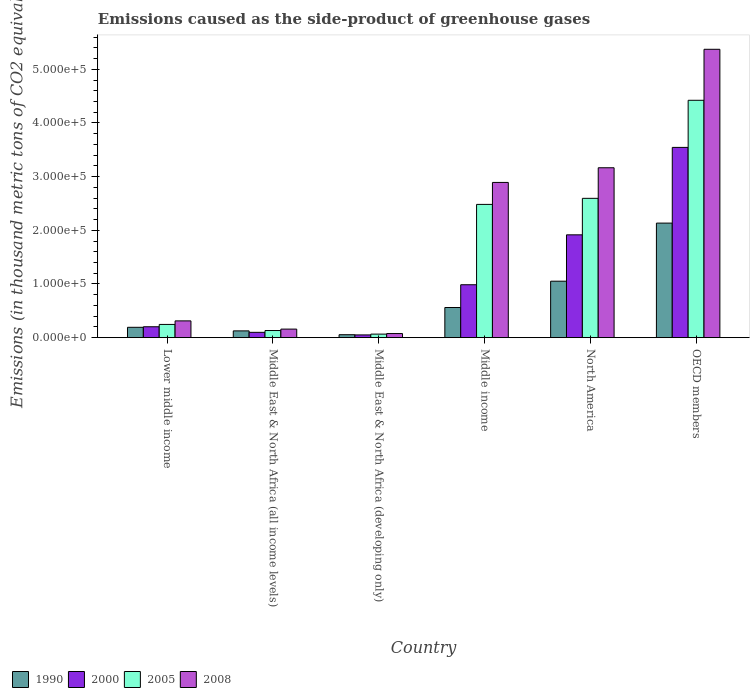How many groups of bars are there?
Your answer should be very brief. 6. Are the number of bars per tick equal to the number of legend labels?
Your answer should be compact. Yes. How many bars are there on the 6th tick from the left?
Keep it short and to the point. 4. What is the label of the 6th group of bars from the left?
Provide a succinct answer. OECD members. In how many cases, is the number of bars for a given country not equal to the number of legend labels?
Make the answer very short. 0. What is the emissions caused as the side-product of greenhouse gases in 1990 in Middle East & North Africa (all income levels)?
Give a very brief answer. 1.26e+04. Across all countries, what is the maximum emissions caused as the side-product of greenhouse gases in 2005?
Provide a succinct answer. 4.42e+05. Across all countries, what is the minimum emissions caused as the side-product of greenhouse gases in 1990?
Provide a succinct answer. 5502.6. In which country was the emissions caused as the side-product of greenhouse gases in 2005 minimum?
Provide a short and direct response. Middle East & North Africa (developing only). What is the total emissions caused as the side-product of greenhouse gases in 1990 in the graph?
Offer a terse response. 4.12e+05. What is the difference between the emissions caused as the side-product of greenhouse gases in 2008 in Middle East & North Africa (all income levels) and that in OECD members?
Make the answer very short. -5.21e+05. What is the difference between the emissions caused as the side-product of greenhouse gases in 2005 in Middle East & North Africa (all income levels) and the emissions caused as the side-product of greenhouse gases in 2000 in Middle income?
Your answer should be very brief. -8.53e+04. What is the average emissions caused as the side-product of greenhouse gases in 2008 per country?
Your response must be concise. 2.00e+05. What is the difference between the emissions caused as the side-product of greenhouse gases of/in 2005 and emissions caused as the side-product of greenhouse gases of/in 2008 in OECD members?
Keep it short and to the point. -9.50e+04. What is the ratio of the emissions caused as the side-product of greenhouse gases in 2000 in Middle East & North Africa (all income levels) to that in North America?
Ensure brevity in your answer.  0.05. Is the emissions caused as the side-product of greenhouse gases in 1990 in Middle income less than that in North America?
Ensure brevity in your answer.  Yes. What is the difference between the highest and the second highest emissions caused as the side-product of greenhouse gases in 2000?
Your response must be concise. -9.30e+04. What is the difference between the highest and the lowest emissions caused as the side-product of greenhouse gases in 2008?
Offer a terse response. 5.30e+05. In how many countries, is the emissions caused as the side-product of greenhouse gases in 2000 greater than the average emissions caused as the side-product of greenhouse gases in 2000 taken over all countries?
Keep it short and to the point. 2. Is the sum of the emissions caused as the side-product of greenhouse gases in 2005 in Middle East & North Africa (developing only) and OECD members greater than the maximum emissions caused as the side-product of greenhouse gases in 1990 across all countries?
Your response must be concise. Yes. Is it the case that in every country, the sum of the emissions caused as the side-product of greenhouse gases in 2008 and emissions caused as the side-product of greenhouse gases in 2005 is greater than the sum of emissions caused as the side-product of greenhouse gases in 1990 and emissions caused as the side-product of greenhouse gases in 2000?
Offer a terse response. No. What does the 3rd bar from the left in North America represents?
Your answer should be very brief. 2005. How many bars are there?
Ensure brevity in your answer.  24. What is the difference between two consecutive major ticks on the Y-axis?
Provide a short and direct response. 1.00e+05. Does the graph contain any zero values?
Your answer should be very brief. No. Where does the legend appear in the graph?
Your answer should be very brief. Bottom left. How many legend labels are there?
Make the answer very short. 4. What is the title of the graph?
Your response must be concise. Emissions caused as the side-product of greenhouse gases. Does "1971" appear as one of the legend labels in the graph?
Offer a terse response. No. What is the label or title of the X-axis?
Your response must be concise. Country. What is the label or title of the Y-axis?
Offer a very short reply. Emissions (in thousand metric tons of CO2 equivalent). What is the Emissions (in thousand metric tons of CO2 equivalent) of 1990 in Lower middle income?
Keep it short and to the point. 1.93e+04. What is the Emissions (in thousand metric tons of CO2 equivalent) in 2000 in Lower middle income?
Ensure brevity in your answer.  2.03e+04. What is the Emissions (in thousand metric tons of CO2 equivalent) in 2005 in Lower middle income?
Ensure brevity in your answer.  2.47e+04. What is the Emissions (in thousand metric tons of CO2 equivalent) in 2008 in Lower middle income?
Your response must be concise. 3.13e+04. What is the Emissions (in thousand metric tons of CO2 equivalent) in 1990 in Middle East & North Africa (all income levels)?
Your answer should be very brief. 1.26e+04. What is the Emissions (in thousand metric tons of CO2 equivalent) of 2000 in Middle East & North Africa (all income levels)?
Offer a very short reply. 9923.6. What is the Emissions (in thousand metric tons of CO2 equivalent) in 2005 in Middle East & North Africa (all income levels)?
Provide a short and direct response. 1.33e+04. What is the Emissions (in thousand metric tons of CO2 equivalent) in 2008 in Middle East & North Africa (all income levels)?
Make the answer very short. 1.60e+04. What is the Emissions (in thousand metric tons of CO2 equivalent) in 1990 in Middle East & North Africa (developing only)?
Provide a short and direct response. 5502.6. What is the Emissions (in thousand metric tons of CO2 equivalent) of 2000 in Middle East & North Africa (developing only)?
Give a very brief answer. 5124.9. What is the Emissions (in thousand metric tons of CO2 equivalent) in 2005 in Middle East & North Africa (developing only)?
Your response must be concise. 6617.8. What is the Emissions (in thousand metric tons of CO2 equivalent) in 2008 in Middle East & North Africa (developing only)?
Provide a short and direct response. 7657.2. What is the Emissions (in thousand metric tons of CO2 equivalent) of 1990 in Middle income?
Provide a succinct answer. 5.62e+04. What is the Emissions (in thousand metric tons of CO2 equivalent) of 2000 in Middle income?
Your answer should be compact. 9.86e+04. What is the Emissions (in thousand metric tons of CO2 equivalent) in 2005 in Middle income?
Offer a very short reply. 2.48e+05. What is the Emissions (in thousand metric tons of CO2 equivalent) in 2008 in Middle income?
Make the answer very short. 2.89e+05. What is the Emissions (in thousand metric tons of CO2 equivalent) of 1990 in North America?
Offer a very short reply. 1.05e+05. What is the Emissions (in thousand metric tons of CO2 equivalent) in 2000 in North America?
Provide a succinct answer. 1.92e+05. What is the Emissions (in thousand metric tons of CO2 equivalent) of 2005 in North America?
Keep it short and to the point. 2.60e+05. What is the Emissions (in thousand metric tons of CO2 equivalent) in 2008 in North America?
Your answer should be compact. 3.17e+05. What is the Emissions (in thousand metric tons of CO2 equivalent) of 1990 in OECD members?
Keep it short and to the point. 2.13e+05. What is the Emissions (in thousand metric tons of CO2 equivalent) of 2000 in OECD members?
Keep it short and to the point. 3.54e+05. What is the Emissions (in thousand metric tons of CO2 equivalent) of 2005 in OECD members?
Keep it short and to the point. 4.42e+05. What is the Emissions (in thousand metric tons of CO2 equivalent) of 2008 in OECD members?
Your answer should be compact. 5.37e+05. Across all countries, what is the maximum Emissions (in thousand metric tons of CO2 equivalent) of 1990?
Make the answer very short. 2.13e+05. Across all countries, what is the maximum Emissions (in thousand metric tons of CO2 equivalent) of 2000?
Provide a short and direct response. 3.54e+05. Across all countries, what is the maximum Emissions (in thousand metric tons of CO2 equivalent) in 2005?
Ensure brevity in your answer.  4.42e+05. Across all countries, what is the maximum Emissions (in thousand metric tons of CO2 equivalent) in 2008?
Give a very brief answer. 5.37e+05. Across all countries, what is the minimum Emissions (in thousand metric tons of CO2 equivalent) of 1990?
Offer a very short reply. 5502.6. Across all countries, what is the minimum Emissions (in thousand metric tons of CO2 equivalent) of 2000?
Provide a short and direct response. 5124.9. Across all countries, what is the minimum Emissions (in thousand metric tons of CO2 equivalent) of 2005?
Your answer should be very brief. 6617.8. Across all countries, what is the minimum Emissions (in thousand metric tons of CO2 equivalent) of 2008?
Offer a terse response. 7657.2. What is the total Emissions (in thousand metric tons of CO2 equivalent) of 1990 in the graph?
Your response must be concise. 4.12e+05. What is the total Emissions (in thousand metric tons of CO2 equivalent) in 2000 in the graph?
Ensure brevity in your answer.  6.80e+05. What is the total Emissions (in thousand metric tons of CO2 equivalent) in 2005 in the graph?
Provide a succinct answer. 9.95e+05. What is the total Emissions (in thousand metric tons of CO2 equivalent) of 2008 in the graph?
Offer a very short reply. 1.20e+06. What is the difference between the Emissions (in thousand metric tons of CO2 equivalent) in 1990 in Lower middle income and that in Middle East & North Africa (all income levels)?
Offer a terse response. 6670.8. What is the difference between the Emissions (in thousand metric tons of CO2 equivalent) of 2000 in Lower middle income and that in Middle East & North Africa (all income levels)?
Keep it short and to the point. 1.04e+04. What is the difference between the Emissions (in thousand metric tons of CO2 equivalent) in 2005 in Lower middle income and that in Middle East & North Africa (all income levels)?
Make the answer very short. 1.13e+04. What is the difference between the Emissions (in thousand metric tons of CO2 equivalent) in 2008 in Lower middle income and that in Middle East & North Africa (all income levels)?
Your answer should be very brief. 1.53e+04. What is the difference between the Emissions (in thousand metric tons of CO2 equivalent) of 1990 in Lower middle income and that in Middle East & North Africa (developing only)?
Your answer should be compact. 1.38e+04. What is the difference between the Emissions (in thousand metric tons of CO2 equivalent) in 2000 in Lower middle income and that in Middle East & North Africa (developing only)?
Make the answer very short. 1.52e+04. What is the difference between the Emissions (in thousand metric tons of CO2 equivalent) in 2005 in Lower middle income and that in Middle East & North Africa (developing only)?
Your answer should be compact. 1.80e+04. What is the difference between the Emissions (in thousand metric tons of CO2 equivalent) of 2008 in Lower middle income and that in Middle East & North Africa (developing only)?
Ensure brevity in your answer.  2.36e+04. What is the difference between the Emissions (in thousand metric tons of CO2 equivalent) of 1990 in Lower middle income and that in Middle income?
Provide a succinct answer. -3.69e+04. What is the difference between the Emissions (in thousand metric tons of CO2 equivalent) of 2000 in Lower middle income and that in Middle income?
Offer a very short reply. -7.83e+04. What is the difference between the Emissions (in thousand metric tons of CO2 equivalent) of 2005 in Lower middle income and that in Middle income?
Offer a terse response. -2.24e+05. What is the difference between the Emissions (in thousand metric tons of CO2 equivalent) in 2008 in Lower middle income and that in Middle income?
Your answer should be very brief. -2.58e+05. What is the difference between the Emissions (in thousand metric tons of CO2 equivalent) in 1990 in Lower middle income and that in North America?
Make the answer very short. -8.59e+04. What is the difference between the Emissions (in thousand metric tons of CO2 equivalent) of 2000 in Lower middle income and that in North America?
Provide a succinct answer. -1.71e+05. What is the difference between the Emissions (in thousand metric tons of CO2 equivalent) in 2005 in Lower middle income and that in North America?
Offer a terse response. -2.35e+05. What is the difference between the Emissions (in thousand metric tons of CO2 equivalent) in 2008 in Lower middle income and that in North America?
Provide a short and direct response. -2.85e+05. What is the difference between the Emissions (in thousand metric tons of CO2 equivalent) of 1990 in Lower middle income and that in OECD members?
Offer a terse response. -1.94e+05. What is the difference between the Emissions (in thousand metric tons of CO2 equivalent) in 2000 in Lower middle income and that in OECD members?
Provide a short and direct response. -3.34e+05. What is the difference between the Emissions (in thousand metric tons of CO2 equivalent) of 2005 in Lower middle income and that in OECD members?
Keep it short and to the point. -4.18e+05. What is the difference between the Emissions (in thousand metric tons of CO2 equivalent) in 2008 in Lower middle income and that in OECD members?
Offer a very short reply. -5.06e+05. What is the difference between the Emissions (in thousand metric tons of CO2 equivalent) in 1990 in Middle East & North Africa (all income levels) and that in Middle East & North Africa (developing only)?
Your answer should be very brief. 7133. What is the difference between the Emissions (in thousand metric tons of CO2 equivalent) of 2000 in Middle East & North Africa (all income levels) and that in Middle East & North Africa (developing only)?
Provide a succinct answer. 4798.7. What is the difference between the Emissions (in thousand metric tons of CO2 equivalent) of 2005 in Middle East & North Africa (all income levels) and that in Middle East & North Africa (developing only)?
Give a very brief answer. 6694.2. What is the difference between the Emissions (in thousand metric tons of CO2 equivalent) in 2008 in Middle East & North Africa (all income levels) and that in Middle East & North Africa (developing only)?
Your response must be concise. 8295.8. What is the difference between the Emissions (in thousand metric tons of CO2 equivalent) of 1990 in Middle East & North Africa (all income levels) and that in Middle income?
Offer a very short reply. -4.35e+04. What is the difference between the Emissions (in thousand metric tons of CO2 equivalent) of 2000 in Middle East & North Africa (all income levels) and that in Middle income?
Keep it short and to the point. -8.87e+04. What is the difference between the Emissions (in thousand metric tons of CO2 equivalent) in 2005 in Middle East & North Africa (all income levels) and that in Middle income?
Keep it short and to the point. -2.35e+05. What is the difference between the Emissions (in thousand metric tons of CO2 equivalent) of 2008 in Middle East & North Africa (all income levels) and that in Middle income?
Offer a terse response. -2.73e+05. What is the difference between the Emissions (in thousand metric tons of CO2 equivalent) in 1990 in Middle East & North Africa (all income levels) and that in North America?
Give a very brief answer. -9.26e+04. What is the difference between the Emissions (in thousand metric tons of CO2 equivalent) of 2000 in Middle East & North Africa (all income levels) and that in North America?
Make the answer very short. -1.82e+05. What is the difference between the Emissions (in thousand metric tons of CO2 equivalent) of 2005 in Middle East & North Africa (all income levels) and that in North America?
Keep it short and to the point. -2.46e+05. What is the difference between the Emissions (in thousand metric tons of CO2 equivalent) in 2008 in Middle East & North Africa (all income levels) and that in North America?
Provide a succinct answer. -3.01e+05. What is the difference between the Emissions (in thousand metric tons of CO2 equivalent) of 1990 in Middle East & North Africa (all income levels) and that in OECD members?
Provide a short and direct response. -2.01e+05. What is the difference between the Emissions (in thousand metric tons of CO2 equivalent) of 2000 in Middle East & North Africa (all income levels) and that in OECD members?
Make the answer very short. -3.45e+05. What is the difference between the Emissions (in thousand metric tons of CO2 equivalent) of 2005 in Middle East & North Africa (all income levels) and that in OECD members?
Keep it short and to the point. -4.29e+05. What is the difference between the Emissions (in thousand metric tons of CO2 equivalent) in 2008 in Middle East & North Africa (all income levels) and that in OECD members?
Ensure brevity in your answer.  -5.21e+05. What is the difference between the Emissions (in thousand metric tons of CO2 equivalent) in 1990 in Middle East & North Africa (developing only) and that in Middle income?
Make the answer very short. -5.07e+04. What is the difference between the Emissions (in thousand metric tons of CO2 equivalent) in 2000 in Middle East & North Africa (developing only) and that in Middle income?
Provide a succinct answer. -9.35e+04. What is the difference between the Emissions (in thousand metric tons of CO2 equivalent) of 2005 in Middle East & North Africa (developing only) and that in Middle income?
Keep it short and to the point. -2.42e+05. What is the difference between the Emissions (in thousand metric tons of CO2 equivalent) of 2008 in Middle East & North Africa (developing only) and that in Middle income?
Your answer should be compact. -2.82e+05. What is the difference between the Emissions (in thousand metric tons of CO2 equivalent) in 1990 in Middle East & North Africa (developing only) and that in North America?
Give a very brief answer. -9.97e+04. What is the difference between the Emissions (in thousand metric tons of CO2 equivalent) in 2000 in Middle East & North Africa (developing only) and that in North America?
Offer a terse response. -1.86e+05. What is the difference between the Emissions (in thousand metric tons of CO2 equivalent) of 2005 in Middle East & North Africa (developing only) and that in North America?
Keep it short and to the point. -2.53e+05. What is the difference between the Emissions (in thousand metric tons of CO2 equivalent) in 2008 in Middle East & North Africa (developing only) and that in North America?
Provide a succinct answer. -3.09e+05. What is the difference between the Emissions (in thousand metric tons of CO2 equivalent) in 1990 in Middle East & North Africa (developing only) and that in OECD members?
Ensure brevity in your answer.  -2.08e+05. What is the difference between the Emissions (in thousand metric tons of CO2 equivalent) of 2000 in Middle East & North Africa (developing only) and that in OECD members?
Your answer should be very brief. -3.49e+05. What is the difference between the Emissions (in thousand metric tons of CO2 equivalent) in 2005 in Middle East & North Africa (developing only) and that in OECD members?
Your response must be concise. -4.36e+05. What is the difference between the Emissions (in thousand metric tons of CO2 equivalent) in 2008 in Middle East & North Africa (developing only) and that in OECD members?
Offer a very short reply. -5.30e+05. What is the difference between the Emissions (in thousand metric tons of CO2 equivalent) of 1990 in Middle income and that in North America?
Make the answer very short. -4.90e+04. What is the difference between the Emissions (in thousand metric tons of CO2 equivalent) in 2000 in Middle income and that in North America?
Your answer should be very brief. -9.30e+04. What is the difference between the Emissions (in thousand metric tons of CO2 equivalent) of 2005 in Middle income and that in North America?
Make the answer very short. -1.13e+04. What is the difference between the Emissions (in thousand metric tons of CO2 equivalent) of 2008 in Middle income and that in North America?
Make the answer very short. -2.73e+04. What is the difference between the Emissions (in thousand metric tons of CO2 equivalent) in 1990 in Middle income and that in OECD members?
Make the answer very short. -1.57e+05. What is the difference between the Emissions (in thousand metric tons of CO2 equivalent) in 2000 in Middle income and that in OECD members?
Your response must be concise. -2.56e+05. What is the difference between the Emissions (in thousand metric tons of CO2 equivalent) in 2005 in Middle income and that in OECD members?
Offer a very short reply. -1.94e+05. What is the difference between the Emissions (in thousand metric tons of CO2 equivalent) of 2008 in Middle income and that in OECD members?
Keep it short and to the point. -2.48e+05. What is the difference between the Emissions (in thousand metric tons of CO2 equivalent) of 1990 in North America and that in OECD members?
Offer a very short reply. -1.08e+05. What is the difference between the Emissions (in thousand metric tons of CO2 equivalent) in 2000 in North America and that in OECD members?
Provide a short and direct response. -1.63e+05. What is the difference between the Emissions (in thousand metric tons of CO2 equivalent) of 2005 in North America and that in OECD members?
Offer a terse response. -1.83e+05. What is the difference between the Emissions (in thousand metric tons of CO2 equivalent) in 2008 in North America and that in OECD members?
Your response must be concise. -2.21e+05. What is the difference between the Emissions (in thousand metric tons of CO2 equivalent) of 1990 in Lower middle income and the Emissions (in thousand metric tons of CO2 equivalent) of 2000 in Middle East & North Africa (all income levels)?
Your answer should be very brief. 9382.8. What is the difference between the Emissions (in thousand metric tons of CO2 equivalent) of 1990 in Lower middle income and the Emissions (in thousand metric tons of CO2 equivalent) of 2005 in Middle East & North Africa (all income levels)?
Your answer should be compact. 5994.4. What is the difference between the Emissions (in thousand metric tons of CO2 equivalent) in 1990 in Lower middle income and the Emissions (in thousand metric tons of CO2 equivalent) in 2008 in Middle East & North Africa (all income levels)?
Ensure brevity in your answer.  3353.4. What is the difference between the Emissions (in thousand metric tons of CO2 equivalent) in 2000 in Lower middle income and the Emissions (in thousand metric tons of CO2 equivalent) in 2005 in Middle East & North Africa (all income levels)?
Ensure brevity in your answer.  7002.3. What is the difference between the Emissions (in thousand metric tons of CO2 equivalent) of 2000 in Lower middle income and the Emissions (in thousand metric tons of CO2 equivalent) of 2008 in Middle East & North Africa (all income levels)?
Make the answer very short. 4361.3. What is the difference between the Emissions (in thousand metric tons of CO2 equivalent) of 2005 in Lower middle income and the Emissions (in thousand metric tons of CO2 equivalent) of 2008 in Middle East & North Africa (all income levels)?
Offer a terse response. 8700.4. What is the difference between the Emissions (in thousand metric tons of CO2 equivalent) of 1990 in Lower middle income and the Emissions (in thousand metric tons of CO2 equivalent) of 2000 in Middle East & North Africa (developing only)?
Provide a succinct answer. 1.42e+04. What is the difference between the Emissions (in thousand metric tons of CO2 equivalent) of 1990 in Lower middle income and the Emissions (in thousand metric tons of CO2 equivalent) of 2005 in Middle East & North Africa (developing only)?
Provide a short and direct response. 1.27e+04. What is the difference between the Emissions (in thousand metric tons of CO2 equivalent) in 1990 in Lower middle income and the Emissions (in thousand metric tons of CO2 equivalent) in 2008 in Middle East & North Africa (developing only)?
Ensure brevity in your answer.  1.16e+04. What is the difference between the Emissions (in thousand metric tons of CO2 equivalent) in 2000 in Lower middle income and the Emissions (in thousand metric tons of CO2 equivalent) in 2005 in Middle East & North Africa (developing only)?
Offer a terse response. 1.37e+04. What is the difference between the Emissions (in thousand metric tons of CO2 equivalent) of 2000 in Lower middle income and the Emissions (in thousand metric tons of CO2 equivalent) of 2008 in Middle East & North Africa (developing only)?
Provide a succinct answer. 1.27e+04. What is the difference between the Emissions (in thousand metric tons of CO2 equivalent) in 2005 in Lower middle income and the Emissions (in thousand metric tons of CO2 equivalent) in 2008 in Middle East & North Africa (developing only)?
Offer a very short reply. 1.70e+04. What is the difference between the Emissions (in thousand metric tons of CO2 equivalent) in 1990 in Lower middle income and the Emissions (in thousand metric tons of CO2 equivalent) in 2000 in Middle income?
Provide a succinct answer. -7.93e+04. What is the difference between the Emissions (in thousand metric tons of CO2 equivalent) in 1990 in Lower middle income and the Emissions (in thousand metric tons of CO2 equivalent) in 2005 in Middle income?
Give a very brief answer. -2.29e+05. What is the difference between the Emissions (in thousand metric tons of CO2 equivalent) of 1990 in Lower middle income and the Emissions (in thousand metric tons of CO2 equivalent) of 2008 in Middle income?
Make the answer very short. -2.70e+05. What is the difference between the Emissions (in thousand metric tons of CO2 equivalent) of 2000 in Lower middle income and the Emissions (in thousand metric tons of CO2 equivalent) of 2005 in Middle income?
Provide a succinct answer. -2.28e+05. What is the difference between the Emissions (in thousand metric tons of CO2 equivalent) of 2000 in Lower middle income and the Emissions (in thousand metric tons of CO2 equivalent) of 2008 in Middle income?
Your answer should be very brief. -2.69e+05. What is the difference between the Emissions (in thousand metric tons of CO2 equivalent) in 2005 in Lower middle income and the Emissions (in thousand metric tons of CO2 equivalent) in 2008 in Middle income?
Give a very brief answer. -2.65e+05. What is the difference between the Emissions (in thousand metric tons of CO2 equivalent) of 1990 in Lower middle income and the Emissions (in thousand metric tons of CO2 equivalent) of 2000 in North America?
Provide a short and direct response. -1.72e+05. What is the difference between the Emissions (in thousand metric tons of CO2 equivalent) in 1990 in Lower middle income and the Emissions (in thousand metric tons of CO2 equivalent) in 2005 in North America?
Ensure brevity in your answer.  -2.40e+05. What is the difference between the Emissions (in thousand metric tons of CO2 equivalent) of 1990 in Lower middle income and the Emissions (in thousand metric tons of CO2 equivalent) of 2008 in North America?
Your response must be concise. -2.97e+05. What is the difference between the Emissions (in thousand metric tons of CO2 equivalent) in 2000 in Lower middle income and the Emissions (in thousand metric tons of CO2 equivalent) in 2005 in North America?
Keep it short and to the point. -2.39e+05. What is the difference between the Emissions (in thousand metric tons of CO2 equivalent) in 2000 in Lower middle income and the Emissions (in thousand metric tons of CO2 equivalent) in 2008 in North America?
Offer a terse response. -2.96e+05. What is the difference between the Emissions (in thousand metric tons of CO2 equivalent) of 2005 in Lower middle income and the Emissions (in thousand metric tons of CO2 equivalent) of 2008 in North America?
Give a very brief answer. -2.92e+05. What is the difference between the Emissions (in thousand metric tons of CO2 equivalent) of 1990 in Lower middle income and the Emissions (in thousand metric tons of CO2 equivalent) of 2000 in OECD members?
Provide a short and direct response. -3.35e+05. What is the difference between the Emissions (in thousand metric tons of CO2 equivalent) of 1990 in Lower middle income and the Emissions (in thousand metric tons of CO2 equivalent) of 2005 in OECD members?
Ensure brevity in your answer.  -4.23e+05. What is the difference between the Emissions (in thousand metric tons of CO2 equivalent) of 1990 in Lower middle income and the Emissions (in thousand metric tons of CO2 equivalent) of 2008 in OECD members?
Your response must be concise. -5.18e+05. What is the difference between the Emissions (in thousand metric tons of CO2 equivalent) in 2000 in Lower middle income and the Emissions (in thousand metric tons of CO2 equivalent) in 2005 in OECD members?
Give a very brief answer. -4.22e+05. What is the difference between the Emissions (in thousand metric tons of CO2 equivalent) of 2000 in Lower middle income and the Emissions (in thousand metric tons of CO2 equivalent) of 2008 in OECD members?
Keep it short and to the point. -5.17e+05. What is the difference between the Emissions (in thousand metric tons of CO2 equivalent) in 2005 in Lower middle income and the Emissions (in thousand metric tons of CO2 equivalent) in 2008 in OECD members?
Your response must be concise. -5.13e+05. What is the difference between the Emissions (in thousand metric tons of CO2 equivalent) of 1990 in Middle East & North Africa (all income levels) and the Emissions (in thousand metric tons of CO2 equivalent) of 2000 in Middle East & North Africa (developing only)?
Offer a very short reply. 7510.7. What is the difference between the Emissions (in thousand metric tons of CO2 equivalent) of 1990 in Middle East & North Africa (all income levels) and the Emissions (in thousand metric tons of CO2 equivalent) of 2005 in Middle East & North Africa (developing only)?
Offer a terse response. 6017.8. What is the difference between the Emissions (in thousand metric tons of CO2 equivalent) in 1990 in Middle East & North Africa (all income levels) and the Emissions (in thousand metric tons of CO2 equivalent) in 2008 in Middle East & North Africa (developing only)?
Give a very brief answer. 4978.4. What is the difference between the Emissions (in thousand metric tons of CO2 equivalent) of 2000 in Middle East & North Africa (all income levels) and the Emissions (in thousand metric tons of CO2 equivalent) of 2005 in Middle East & North Africa (developing only)?
Keep it short and to the point. 3305.8. What is the difference between the Emissions (in thousand metric tons of CO2 equivalent) of 2000 in Middle East & North Africa (all income levels) and the Emissions (in thousand metric tons of CO2 equivalent) of 2008 in Middle East & North Africa (developing only)?
Offer a terse response. 2266.4. What is the difference between the Emissions (in thousand metric tons of CO2 equivalent) in 2005 in Middle East & North Africa (all income levels) and the Emissions (in thousand metric tons of CO2 equivalent) in 2008 in Middle East & North Africa (developing only)?
Give a very brief answer. 5654.8. What is the difference between the Emissions (in thousand metric tons of CO2 equivalent) in 1990 in Middle East & North Africa (all income levels) and the Emissions (in thousand metric tons of CO2 equivalent) in 2000 in Middle income?
Provide a short and direct response. -8.60e+04. What is the difference between the Emissions (in thousand metric tons of CO2 equivalent) in 1990 in Middle East & North Africa (all income levels) and the Emissions (in thousand metric tons of CO2 equivalent) in 2005 in Middle income?
Keep it short and to the point. -2.36e+05. What is the difference between the Emissions (in thousand metric tons of CO2 equivalent) in 1990 in Middle East & North Africa (all income levels) and the Emissions (in thousand metric tons of CO2 equivalent) in 2008 in Middle income?
Your response must be concise. -2.77e+05. What is the difference between the Emissions (in thousand metric tons of CO2 equivalent) of 2000 in Middle East & North Africa (all income levels) and the Emissions (in thousand metric tons of CO2 equivalent) of 2005 in Middle income?
Your answer should be compact. -2.38e+05. What is the difference between the Emissions (in thousand metric tons of CO2 equivalent) in 2000 in Middle East & North Africa (all income levels) and the Emissions (in thousand metric tons of CO2 equivalent) in 2008 in Middle income?
Keep it short and to the point. -2.79e+05. What is the difference between the Emissions (in thousand metric tons of CO2 equivalent) in 2005 in Middle East & North Africa (all income levels) and the Emissions (in thousand metric tons of CO2 equivalent) in 2008 in Middle income?
Keep it short and to the point. -2.76e+05. What is the difference between the Emissions (in thousand metric tons of CO2 equivalent) of 1990 in Middle East & North Africa (all income levels) and the Emissions (in thousand metric tons of CO2 equivalent) of 2000 in North America?
Provide a short and direct response. -1.79e+05. What is the difference between the Emissions (in thousand metric tons of CO2 equivalent) in 1990 in Middle East & North Africa (all income levels) and the Emissions (in thousand metric tons of CO2 equivalent) in 2005 in North America?
Ensure brevity in your answer.  -2.47e+05. What is the difference between the Emissions (in thousand metric tons of CO2 equivalent) in 1990 in Middle East & North Africa (all income levels) and the Emissions (in thousand metric tons of CO2 equivalent) in 2008 in North America?
Keep it short and to the point. -3.04e+05. What is the difference between the Emissions (in thousand metric tons of CO2 equivalent) of 2000 in Middle East & North Africa (all income levels) and the Emissions (in thousand metric tons of CO2 equivalent) of 2005 in North America?
Your answer should be very brief. -2.50e+05. What is the difference between the Emissions (in thousand metric tons of CO2 equivalent) in 2000 in Middle East & North Africa (all income levels) and the Emissions (in thousand metric tons of CO2 equivalent) in 2008 in North America?
Offer a very short reply. -3.07e+05. What is the difference between the Emissions (in thousand metric tons of CO2 equivalent) in 2005 in Middle East & North Africa (all income levels) and the Emissions (in thousand metric tons of CO2 equivalent) in 2008 in North America?
Offer a very short reply. -3.03e+05. What is the difference between the Emissions (in thousand metric tons of CO2 equivalent) of 1990 in Middle East & North Africa (all income levels) and the Emissions (in thousand metric tons of CO2 equivalent) of 2000 in OECD members?
Your answer should be compact. -3.42e+05. What is the difference between the Emissions (in thousand metric tons of CO2 equivalent) of 1990 in Middle East & North Africa (all income levels) and the Emissions (in thousand metric tons of CO2 equivalent) of 2005 in OECD members?
Provide a succinct answer. -4.30e+05. What is the difference between the Emissions (in thousand metric tons of CO2 equivalent) in 1990 in Middle East & North Africa (all income levels) and the Emissions (in thousand metric tons of CO2 equivalent) in 2008 in OECD members?
Your answer should be compact. -5.25e+05. What is the difference between the Emissions (in thousand metric tons of CO2 equivalent) in 2000 in Middle East & North Africa (all income levels) and the Emissions (in thousand metric tons of CO2 equivalent) in 2005 in OECD members?
Offer a very short reply. -4.32e+05. What is the difference between the Emissions (in thousand metric tons of CO2 equivalent) of 2000 in Middle East & North Africa (all income levels) and the Emissions (in thousand metric tons of CO2 equivalent) of 2008 in OECD members?
Offer a terse response. -5.27e+05. What is the difference between the Emissions (in thousand metric tons of CO2 equivalent) in 2005 in Middle East & North Africa (all income levels) and the Emissions (in thousand metric tons of CO2 equivalent) in 2008 in OECD members?
Your answer should be very brief. -5.24e+05. What is the difference between the Emissions (in thousand metric tons of CO2 equivalent) of 1990 in Middle East & North Africa (developing only) and the Emissions (in thousand metric tons of CO2 equivalent) of 2000 in Middle income?
Provide a short and direct response. -9.31e+04. What is the difference between the Emissions (in thousand metric tons of CO2 equivalent) in 1990 in Middle East & North Africa (developing only) and the Emissions (in thousand metric tons of CO2 equivalent) in 2005 in Middle income?
Provide a succinct answer. -2.43e+05. What is the difference between the Emissions (in thousand metric tons of CO2 equivalent) of 1990 in Middle East & North Africa (developing only) and the Emissions (in thousand metric tons of CO2 equivalent) of 2008 in Middle income?
Your answer should be compact. -2.84e+05. What is the difference between the Emissions (in thousand metric tons of CO2 equivalent) of 2000 in Middle East & North Africa (developing only) and the Emissions (in thousand metric tons of CO2 equivalent) of 2005 in Middle income?
Make the answer very short. -2.43e+05. What is the difference between the Emissions (in thousand metric tons of CO2 equivalent) of 2000 in Middle East & North Africa (developing only) and the Emissions (in thousand metric tons of CO2 equivalent) of 2008 in Middle income?
Ensure brevity in your answer.  -2.84e+05. What is the difference between the Emissions (in thousand metric tons of CO2 equivalent) of 2005 in Middle East & North Africa (developing only) and the Emissions (in thousand metric tons of CO2 equivalent) of 2008 in Middle income?
Provide a short and direct response. -2.83e+05. What is the difference between the Emissions (in thousand metric tons of CO2 equivalent) in 1990 in Middle East & North Africa (developing only) and the Emissions (in thousand metric tons of CO2 equivalent) in 2000 in North America?
Your response must be concise. -1.86e+05. What is the difference between the Emissions (in thousand metric tons of CO2 equivalent) in 1990 in Middle East & North Africa (developing only) and the Emissions (in thousand metric tons of CO2 equivalent) in 2005 in North America?
Provide a short and direct response. -2.54e+05. What is the difference between the Emissions (in thousand metric tons of CO2 equivalent) of 1990 in Middle East & North Africa (developing only) and the Emissions (in thousand metric tons of CO2 equivalent) of 2008 in North America?
Give a very brief answer. -3.11e+05. What is the difference between the Emissions (in thousand metric tons of CO2 equivalent) in 2000 in Middle East & North Africa (developing only) and the Emissions (in thousand metric tons of CO2 equivalent) in 2005 in North America?
Offer a very short reply. -2.54e+05. What is the difference between the Emissions (in thousand metric tons of CO2 equivalent) in 2000 in Middle East & North Africa (developing only) and the Emissions (in thousand metric tons of CO2 equivalent) in 2008 in North America?
Keep it short and to the point. -3.11e+05. What is the difference between the Emissions (in thousand metric tons of CO2 equivalent) in 2005 in Middle East & North Africa (developing only) and the Emissions (in thousand metric tons of CO2 equivalent) in 2008 in North America?
Give a very brief answer. -3.10e+05. What is the difference between the Emissions (in thousand metric tons of CO2 equivalent) in 1990 in Middle East & North Africa (developing only) and the Emissions (in thousand metric tons of CO2 equivalent) in 2000 in OECD members?
Your response must be concise. -3.49e+05. What is the difference between the Emissions (in thousand metric tons of CO2 equivalent) in 1990 in Middle East & North Africa (developing only) and the Emissions (in thousand metric tons of CO2 equivalent) in 2005 in OECD members?
Ensure brevity in your answer.  -4.37e+05. What is the difference between the Emissions (in thousand metric tons of CO2 equivalent) of 1990 in Middle East & North Africa (developing only) and the Emissions (in thousand metric tons of CO2 equivalent) of 2008 in OECD members?
Your answer should be very brief. -5.32e+05. What is the difference between the Emissions (in thousand metric tons of CO2 equivalent) in 2000 in Middle East & North Africa (developing only) and the Emissions (in thousand metric tons of CO2 equivalent) in 2005 in OECD members?
Your answer should be very brief. -4.37e+05. What is the difference between the Emissions (in thousand metric tons of CO2 equivalent) of 2000 in Middle East & North Africa (developing only) and the Emissions (in thousand metric tons of CO2 equivalent) of 2008 in OECD members?
Your response must be concise. -5.32e+05. What is the difference between the Emissions (in thousand metric tons of CO2 equivalent) in 2005 in Middle East & North Africa (developing only) and the Emissions (in thousand metric tons of CO2 equivalent) in 2008 in OECD members?
Your answer should be very brief. -5.31e+05. What is the difference between the Emissions (in thousand metric tons of CO2 equivalent) of 1990 in Middle income and the Emissions (in thousand metric tons of CO2 equivalent) of 2000 in North America?
Your answer should be very brief. -1.35e+05. What is the difference between the Emissions (in thousand metric tons of CO2 equivalent) in 1990 in Middle income and the Emissions (in thousand metric tons of CO2 equivalent) in 2005 in North America?
Your response must be concise. -2.03e+05. What is the difference between the Emissions (in thousand metric tons of CO2 equivalent) in 1990 in Middle income and the Emissions (in thousand metric tons of CO2 equivalent) in 2008 in North America?
Give a very brief answer. -2.60e+05. What is the difference between the Emissions (in thousand metric tons of CO2 equivalent) in 2000 in Middle income and the Emissions (in thousand metric tons of CO2 equivalent) in 2005 in North America?
Make the answer very short. -1.61e+05. What is the difference between the Emissions (in thousand metric tons of CO2 equivalent) in 2000 in Middle income and the Emissions (in thousand metric tons of CO2 equivalent) in 2008 in North America?
Keep it short and to the point. -2.18e+05. What is the difference between the Emissions (in thousand metric tons of CO2 equivalent) in 2005 in Middle income and the Emissions (in thousand metric tons of CO2 equivalent) in 2008 in North America?
Make the answer very short. -6.83e+04. What is the difference between the Emissions (in thousand metric tons of CO2 equivalent) in 1990 in Middle income and the Emissions (in thousand metric tons of CO2 equivalent) in 2000 in OECD members?
Offer a terse response. -2.98e+05. What is the difference between the Emissions (in thousand metric tons of CO2 equivalent) in 1990 in Middle income and the Emissions (in thousand metric tons of CO2 equivalent) in 2005 in OECD members?
Offer a terse response. -3.86e+05. What is the difference between the Emissions (in thousand metric tons of CO2 equivalent) of 1990 in Middle income and the Emissions (in thousand metric tons of CO2 equivalent) of 2008 in OECD members?
Provide a succinct answer. -4.81e+05. What is the difference between the Emissions (in thousand metric tons of CO2 equivalent) in 2000 in Middle income and the Emissions (in thousand metric tons of CO2 equivalent) in 2005 in OECD members?
Provide a short and direct response. -3.44e+05. What is the difference between the Emissions (in thousand metric tons of CO2 equivalent) of 2000 in Middle income and the Emissions (in thousand metric tons of CO2 equivalent) of 2008 in OECD members?
Make the answer very short. -4.39e+05. What is the difference between the Emissions (in thousand metric tons of CO2 equivalent) in 2005 in Middle income and the Emissions (in thousand metric tons of CO2 equivalent) in 2008 in OECD members?
Offer a very short reply. -2.89e+05. What is the difference between the Emissions (in thousand metric tons of CO2 equivalent) in 1990 in North America and the Emissions (in thousand metric tons of CO2 equivalent) in 2000 in OECD members?
Provide a succinct answer. -2.49e+05. What is the difference between the Emissions (in thousand metric tons of CO2 equivalent) in 1990 in North America and the Emissions (in thousand metric tons of CO2 equivalent) in 2005 in OECD members?
Keep it short and to the point. -3.37e+05. What is the difference between the Emissions (in thousand metric tons of CO2 equivalent) in 1990 in North America and the Emissions (in thousand metric tons of CO2 equivalent) in 2008 in OECD members?
Offer a very short reply. -4.32e+05. What is the difference between the Emissions (in thousand metric tons of CO2 equivalent) of 2000 in North America and the Emissions (in thousand metric tons of CO2 equivalent) of 2005 in OECD members?
Offer a very short reply. -2.51e+05. What is the difference between the Emissions (in thousand metric tons of CO2 equivalent) in 2000 in North America and the Emissions (in thousand metric tons of CO2 equivalent) in 2008 in OECD members?
Keep it short and to the point. -3.46e+05. What is the difference between the Emissions (in thousand metric tons of CO2 equivalent) in 2005 in North America and the Emissions (in thousand metric tons of CO2 equivalent) in 2008 in OECD members?
Your answer should be very brief. -2.78e+05. What is the average Emissions (in thousand metric tons of CO2 equivalent) in 1990 per country?
Your answer should be very brief. 6.87e+04. What is the average Emissions (in thousand metric tons of CO2 equivalent) of 2000 per country?
Provide a short and direct response. 1.13e+05. What is the average Emissions (in thousand metric tons of CO2 equivalent) of 2005 per country?
Your response must be concise. 1.66e+05. What is the average Emissions (in thousand metric tons of CO2 equivalent) in 2008 per country?
Your answer should be compact. 2.00e+05. What is the difference between the Emissions (in thousand metric tons of CO2 equivalent) of 1990 and Emissions (in thousand metric tons of CO2 equivalent) of 2000 in Lower middle income?
Offer a very short reply. -1007.9. What is the difference between the Emissions (in thousand metric tons of CO2 equivalent) of 1990 and Emissions (in thousand metric tons of CO2 equivalent) of 2005 in Lower middle income?
Provide a succinct answer. -5347. What is the difference between the Emissions (in thousand metric tons of CO2 equivalent) in 1990 and Emissions (in thousand metric tons of CO2 equivalent) in 2008 in Lower middle income?
Provide a short and direct response. -1.20e+04. What is the difference between the Emissions (in thousand metric tons of CO2 equivalent) in 2000 and Emissions (in thousand metric tons of CO2 equivalent) in 2005 in Lower middle income?
Provide a short and direct response. -4339.1. What is the difference between the Emissions (in thousand metric tons of CO2 equivalent) in 2000 and Emissions (in thousand metric tons of CO2 equivalent) in 2008 in Lower middle income?
Make the answer very short. -1.10e+04. What is the difference between the Emissions (in thousand metric tons of CO2 equivalent) in 2005 and Emissions (in thousand metric tons of CO2 equivalent) in 2008 in Lower middle income?
Your answer should be compact. -6613.6. What is the difference between the Emissions (in thousand metric tons of CO2 equivalent) in 1990 and Emissions (in thousand metric tons of CO2 equivalent) in 2000 in Middle East & North Africa (all income levels)?
Ensure brevity in your answer.  2712. What is the difference between the Emissions (in thousand metric tons of CO2 equivalent) of 1990 and Emissions (in thousand metric tons of CO2 equivalent) of 2005 in Middle East & North Africa (all income levels)?
Offer a terse response. -676.4. What is the difference between the Emissions (in thousand metric tons of CO2 equivalent) of 1990 and Emissions (in thousand metric tons of CO2 equivalent) of 2008 in Middle East & North Africa (all income levels)?
Provide a succinct answer. -3317.4. What is the difference between the Emissions (in thousand metric tons of CO2 equivalent) of 2000 and Emissions (in thousand metric tons of CO2 equivalent) of 2005 in Middle East & North Africa (all income levels)?
Your response must be concise. -3388.4. What is the difference between the Emissions (in thousand metric tons of CO2 equivalent) in 2000 and Emissions (in thousand metric tons of CO2 equivalent) in 2008 in Middle East & North Africa (all income levels)?
Your response must be concise. -6029.4. What is the difference between the Emissions (in thousand metric tons of CO2 equivalent) of 2005 and Emissions (in thousand metric tons of CO2 equivalent) of 2008 in Middle East & North Africa (all income levels)?
Keep it short and to the point. -2641. What is the difference between the Emissions (in thousand metric tons of CO2 equivalent) of 1990 and Emissions (in thousand metric tons of CO2 equivalent) of 2000 in Middle East & North Africa (developing only)?
Give a very brief answer. 377.7. What is the difference between the Emissions (in thousand metric tons of CO2 equivalent) of 1990 and Emissions (in thousand metric tons of CO2 equivalent) of 2005 in Middle East & North Africa (developing only)?
Offer a terse response. -1115.2. What is the difference between the Emissions (in thousand metric tons of CO2 equivalent) of 1990 and Emissions (in thousand metric tons of CO2 equivalent) of 2008 in Middle East & North Africa (developing only)?
Your answer should be very brief. -2154.6. What is the difference between the Emissions (in thousand metric tons of CO2 equivalent) of 2000 and Emissions (in thousand metric tons of CO2 equivalent) of 2005 in Middle East & North Africa (developing only)?
Ensure brevity in your answer.  -1492.9. What is the difference between the Emissions (in thousand metric tons of CO2 equivalent) in 2000 and Emissions (in thousand metric tons of CO2 equivalent) in 2008 in Middle East & North Africa (developing only)?
Your response must be concise. -2532.3. What is the difference between the Emissions (in thousand metric tons of CO2 equivalent) of 2005 and Emissions (in thousand metric tons of CO2 equivalent) of 2008 in Middle East & North Africa (developing only)?
Ensure brevity in your answer.  -1039.4. What is the difference between the Emissions (in thousand metric tons of CO2 equivalent) in 1990 and Emissions (in thousand metric tons of CO2 equivalent) in 2000 in Middle income?
Your response must be concise. -4.24e+04. What is the difference between the Emissions (in thousand metric tons of CO2 equivalent) of 1990 and Emissions (in thousand metric tons of CO2 equivalent) of 2005 in Middle income?
Give a very brief answer. -1.92e+05. What is the difference between the Emissions (in thousand metric tons of CO2 equivalent) of 1990 and Emissions (in thousand metric tons of CO2 equivalent) of 2008 in Middle income?
Provide a succinct answer. -2.33e+05. What is the difference between the Emissions (in thousand metric tons of CO2 equivalent) of 2000 and Emissions (in thousand metric tons of CO2 equivalent) of 2005 in Middle income?
Make the answer very short. -1.50e+05. What is the difference between the Emissions (in thousand metric tons of CO2 equivalent) in 2000 and Emissions (in thousand metric tons of CO2 equivalent) in 2008 in Middle income?
Your answer should be very brief. -1.91e+05. What is the difference between the Emissions (in thousand metric tons of CO2 equivalent) of 2005 and Emissions (in thousand metric tons of CO2 equivalent) of 2008 in Middle income?
Your response must be concise. -4.09e+04. What is the difference between the Emissions (in thousand metric tons of CO2 equivalent) of 1990 and Emissions (in thousand metric tons of CO2 equivalent) of 2000 in North America?
Your answer should be compact. -8.64e+04. What is the difference between the Emissions (in thousand metric tons of CO2 equivalent) in 1990 and Emissions (in thousand metric tons of CO2 equivalent) in 2005 in North America?
Your answer should be very brief. -1.54e+05. What is the difference between the Emissions (in thousand metric tons of CO2 equivalent) of 1990 and Emissions (in thousand metric tons of CO2 equivalent) of 2008 in North America?
Provide a succinct answer. -2.11e+05. What is the difference between the Emissions (in thousand metric tons of CO2 equivalent) of 2000 and Emissions (in thousand metric tons of CO2 equivalent) of 2005 in North America?
Offer a terse response. -6.80e+04. What is the difference between the Emissions (in thousand metric tons of CO2 equivalent) of 2000 and Emissions (in thousand metric tons of CO2 equivalent) of 2008 in North America?
Your response must be concise. -1.25e+05. What is the difference between the Emissions (in thousand metric tons of CO2 equivalent) in 2005 and Emissions (in thousand metric tons of CO2 equivalent) in 2008 in North America?
Provide a succinct answer. -5.70e+04. What is the difference between the Emissions (in thousand metric tons of CO2 equivalent) in 1990 and Emissions (in thousand metric tons of CO2 equivalent) in 2000 in OECD members?
Offer a terse response. -1.41e+05. What is the difference between the Emissions (in thousand metric tons of CO2 equivalent) in 1990 and Emissions (in thousand metric tons of CO2 equivalent) in 2005 in OECD members?
Make the answer very short. -2.29e+05. What is the difference between the Emissions (in thousand metric tons of CO2 equivalent) in 1990 and Emissions (in thousand metric tons of CO2 equivalent) in 2008 in OECD members?
Offer a very short reply. -3.24e+05. What is the difference between the Emissions (in thousand metric tons of CO2 equivalent) in 2000 and Emissions (in thousand metric tons of CO2 equivalent) in 2005 in OECD members?
Keep it short and to the point. -8.78e+04. What is the difference between the Emissions (in thousand metric tons of CO2 equivalent) in 2000 and Emissions (in thousand metric tons of CO2 equivalent) in 2008 in OECD members?
Your response must be concise. -1.83e+05. What is the difference between the Emissions (in thousand metric tons of CO2 equivalent) in 2005 and Emissions (in thousand metric tons of CO2 equivalent) in 2008 in OECD members?
Give a very brief answer. -9.50e+04. What is the ratio of the Emissions (in thousand metric tons of CO2 equivalent) in 1990 in Lower middle income to that in Middle East & North Africa (all income levels)?
Your response must be concise. 1.53. What is the ratio of the Emissions (in thousand metric tons of CO2 equivalent) of 2000 in Lower middle income to that in Middle East & North Africa (all income levels)?
Your answer should be compact. 2.05. What is the ratio of the Emissions (in thousand metric tons of CO2 equivalent) of 2005 in Lower middle income to that in Middle East & North Africa (all income levels)?
Make the answer very short. 1.85. What is the ratio of the Emissions (in thousand metric tons of CO2 equivalent) of 2008 in Lower middle income to that in Middle East & North Africa (all income levels)?
Offer a terse response. 1.96. What is the ratio of the Emissions (in thousand metric tons of CO2 equivalent) in 1990 in Lower middle income to that in Middle East & North Africa (developing only)?
Provide a short and direct response. 3.51. What is the ratio of the Emissions (in thousand metric tons of CO2 equivalent) in 2000 in Lower middle income to that in Middle East & North Africa (developing only)?
Give a very brief answer. 3.96. What is the ratio of the Emissions (in thousand metric tons of CO2 equivalent) in 2005 in Lower middle income to that in Middle East & North Africa (developing only)?
Give a very brief answer. 3.73. What is the ratio of the Emissions (in thousand metric tons of CO2 equivalent) of 2008 in Lower middle income to that in Middle East & North Africa (developing only)?
Keep it short and to the point. 4.08. What is the ratio of the Emissions (in thousand metric tons of CO2 equivalent) of 1990 in Lower middle income to that in Middle income?
Your answer should be very brief. 0.34. What is the ratio of the Emissions (in thousand metric tons of CO2 equivalent) in 2000 in Lower middle income to that in Middle income?
Ensure brevity in your answer.  0.21. What is the ratio of the Emissions (in thousand metric tons of CO2 equivalent) in 2005 in Lower middle income to that in Middle income?
Offer a terse response. 0.1. What is the ratio of the Emissions (in thousand metric tons of CO2 equivalent) in 2008 in Lower middle income to that in Middle income?
Make the answer very short. 0.11. What is the ratio of the Emissions (in thousand metric tons of CO2 equivalent) in 1990 in Lower middle income to that in North America?
Give a very brief answer. 0.18. What is the ratio of the Emissions (in thousand metric tons of CO2 equivalent) of 2000 in Lower middle income to that in North America?
Offer a terse response. 0.11. What is the ratio of the Emissions (in thousand metric tons of CO2 equivalent) in 2005 in Lower middle income to that in North America?
Provide a succinct answer. 0.1. What is the ratio of the Emissions (in thousand metric tons of CO2 equivalent) of 2008 in Lower middle income to that in North America?
Ensure brevity in your answer.  0.1. What is the ratio of the Emissions (in thousand metric tons of CO2 equivalent) of 1990 in Lower middle income to that in OECD members?
Make the answer very short. 0.09. What is the ratio of the Emissions (in thousand metric tons of CO2 equivalent) of 2000 in Lower middle income to that in OECD members?
Ensure brevity in your answer.  0.06. What is the ratio of the Emissions (in thousand metric tons of CO2 equivalent) in 2005 in Lower middle income to that in OECD members?
Keep it short and to the point. 0.06. What is the ratio of the Emissions (in thousand metric tons of CO2 equivalent) in 2008 in Lower middle income to that in OECD members?
Provide a short and direct response. 0.06. What is the ratio of the Emissions (in thousand metric tons of CO2 equivalent) of 1990 in Middle East & North Africa (all income levels) to that in Middle East & North Africa (developing only)?
Ensure brevity in your answer.  2.3. What is the ratio of the Emissions (in thousand metric tons of CO2 equivalent) of 2000 in Middle East & North Africa (all income levels) to that in Middle East & North Africa (developing only)?
Your response must be concise. 1.94. What is the ratio of the Emissions (in thousand metric tons of CO2 equivalent) in 2005 in Middle East & North Africa (all income levels) to that in Middle East & North Africa (developing only)?
Keep it short and to the point. 2.01. What is the ratio of the Emissions (in thousand metric tons of CO2 equivalent) in 2008 in Middle East & North Africa (all income levels) to that in Middle East & North Africa (developing only)?
Your response must be concise. 2.08. What is the ratio of the Emissions (in thousand metric tons of CO2 equivalent) of 1990 in Middle East & North Africa (all income levels) to that in Middle income?
Your response must be concise. 0.22. What is the ratio of the Emissions (in thousand metric tons of CO2 equivalent) in 2000 in Middle East & North Africa (all income levels) to that in Middle income?
Offer a very short reply. 0.1. What is the ratio of the Emissions (in thousand metric tons of CO2 equivalent) of 2005 in Middle East & North Africa (all income levels) to that in Middle income?
Ensure brevity in your answer.  0.05. What is the ratio of the Emissions (in thousand metric tons of CO2 equivalent) of 2008 in Middle East & North Africa (all income levels) to that in Middle income?
Your response must be concise. 0.06. What is the ratio of the Emissions (in thousand metric tons of CO2 equivalent) in 1990 in Middle East & North Africa (all income levels) to that in North America?
Provide a short and direct response. 0.12. What is the ratio of the Emissions (in thousand metric tons of CO2 equivalent) of 2000 in Middle East & North Africa (all income levels) to that in North America?
Give a very brief answer. 0.05. What is the ratio of the Emissions (in thousand metric tons of CO2 equivalent) in 2005 in Middle East & North Africa (all income levels) to that in North America?
Your answer should be compact. 0.05. What is the ratio of the Emissions (in thousand metric tons of CO2 equivalent) of 2008 in Middle East & North Africa (all income levels) to that in North America?
Offer a terse response. 0.05. What is the ratio of the Emissions (in thousand metric tons of CO2 equivalent) of 1990 in Middle East & North Africa (all income levels) to that in OECD members?
Your answer should be compact. 0.06. What is the ratio of the Emissions (in thousand metric tons of CO2 equivalent) in 2000 in Middle East & North Africa (all income levels) to that in OECD members?
Your answer should be compact. 0.03. What is the ratio of the Emissions (in thousand metric tons of CO2 equivalent) of 2005 in Middle East & North Africa (all income levels) to that in OECD members?
Keep it short and to the point. 0.03. What is the ratio of the Emissions (in thousand metric tons of CO2 equivalent) in 2008 in Middle East & North Africa (all income levels) to that in OECD members?
Offer a very short reply. 0.03. What is the ratio of the Emissions (in thousand metric tons of CO2 equivalent) in 1990 in Middle East & North Africa (developing only) to that in Middle income?
Your answer should be compact. 0.1. What is the ratio of the Emissions (in thousand metric tons of CO2 equivalent) of 2000 in Middle East & North Africa (developing only) to that in Middle income?
Offer a very short reply. 0.05. What is the ratio of the Emissions (in thousand metric tons of CO2 equivalent) in 2005 in Middle East & North Africa (developing only) to that in Middle income?
Ensure brevity in your answer.  0.03. What is the ratio of the Emissions (in thousand metric tons of CO2 equivalent) in 2008 in Middle East & North Africa (developing only) to that in Middle income?
Offer a very short reply. 0.03. What is the ratio of the Emissions (in thousand metric tons of CO2 equivalent) in 1990 in Middle East & North Africa (developing only) to that in North America?
Offer a terse response. 0.05. What is the ratio of the Emissions (in thousand metric tons of CO2 equivalent) of 2000 in Middle East & North Africa (developing only) to that in North America?
Make the answer very short. 0.03. What is the ratio of the Emissions (in thousand metric tons of CO2 equivalent) in 2005 in Middle East & North Africa (developing only) to that in North America?
Your answer should be very brief. 0.03. What is the ratio of the Emissions (in thousand metric tons of CO2 equivalent) in 2008 in Middle East & North Africa (developing only) to that in North America?
Your answer should be compact. 0.02. What is the ratio of the Emissions (in thousand metric tons of CO2 equivalent) of 1990 in Middle East & North Africa (developing only) to that in OECD members?
Give a very brief answer. 0.03. What is the ratio of the Emissions (in thousand metric tons of CO2 equivalent) in 2000 in Middle East & North Africa (developing only) to that in OECD members?
Your response must be concise. 0.01. What is the ratio of the Emissions (in thousand metric tons of CO2 equivalent) in 2005 in Middle East & North Africa (developing only) to that in OECD members?
Offer a very short reply. 0.01. What is the ratio of the Emissions (in thousand metric tons of CO2 equivalent) in 2008 in Middle East & North Africa (developing only) to that in OECD members?
Keep it short and to the point. 0.01. What is the ratio of the Emissions (in thousand metric tons of CO2 equivalent) of 1990 in Middle income to that in North America?
Offer a terse response. 0.53. What is the ratio of the Emissions (in thousand metric tons of CO2 equivalent) in 2000 in Middle income to that in North America?
Ensure brevity in your answer.  0.51. What is the ratio of the Emissions (in thousand metric tons of CO2 equivalent) of 2005 in Middle income to that in North America?
Keep it short and to the point. 0.96. What is the ratio of the Emissions (in thousand metric tons of CO2 equivalent) of 2008 in Middle income to that in North America?
Offer a terse response. 0.91. What is the ratio of the Emissions (in thousand metric tons of CO2 equivalent) in 1990 in Middle income to that in OECD members?
Provide a succinct answer. 0.26. What is the ratio of the Emissions (in thousand metric tons of CO2 equivalent) of 2000 in Middle income to that in OECD members?
Ensure brevity in your answer.  0.28. What is the ratio of the Emissions (in thousand metric tons of CO2 equivalent) in 2005 in Middle income to that in OECD members?
Make the answer very short. 0.56. What is the ratio of the Emissions (in thousand metric tons of CO2 equivalent) in 2008 in Middle income to that in OECD members?
Your answer should be compact. 0.54. What is the ratio of the Emissions (in thousand metric tons of CO2 equivalent) in 1990 in North America to that in OECD members?
Your answer should be very brief. 0.49. What is the ratio of the Emissions (in thousand metric tons of CO2 equivalent) in 2000 in North America to that in OECD members?
Ensure brevity in your answer.  0.54. What is the ratio of the Emissions (in thousand metric tons of CO2 equivalent) in 2005 in North America to that in OECD members?
Provide a short and direct response. 0.59. What is the ratio of the Emissions (in thousand metric tons of CO2 equivalent) of 2008 in North America to that in OECD members?
Your answer should be very brief. 0.59. What is the difference between the highest and the second highest Emissions (in thousand metric tons of CO2 equivalent) of 1990?
Offer a very short reply. 1.08e+05. What is the difference between the highest and the second highest Emissions (in thousand metric tons of CO2 equivalent) of 2000?
Make the answer very short. 1.63e+05. What is the difference between the highest and the second highest Emissions (in thousand metric tons of CO2 equivalent) of 2005?
Your response must be concise. 1.83e+05. What is the difference between the highest and the second highest Emissions (in thousand metric tons of CO2 equivalent) in 2008?
Offer a very short reply. 2.21e+05. What is the difference between the highest and the lowest Emissions (in thousand metric tons of CO2 equivalent) in 1990?
Provide a succinct answer. 2.08e+05. What is the difference between the highest and the lowest Emissions (in thousand metric tons of CO2 equivalent) of 2000?
Give a very brief answer. 3.49e+05. What is the difference between the highest and the lowest Emissions (in thousand metric tons of CO2 equivalent) of 2005?
Offer a very short reply. 4.36e+05. What is the difference between the highest and the lowest Emissions (in thousand metric tons of CO2 equivalent) of 2008?
Give a very brief answer. 5.30e+05. 